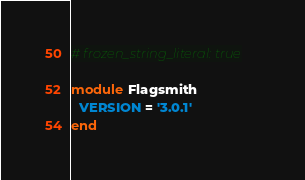<code> <loc_0><loc_0><loc_500><loc_500><_Ruby_># frozen_string_literal: true

module Flagsmith
  VERSION = '3.0.1'
end
</code> 